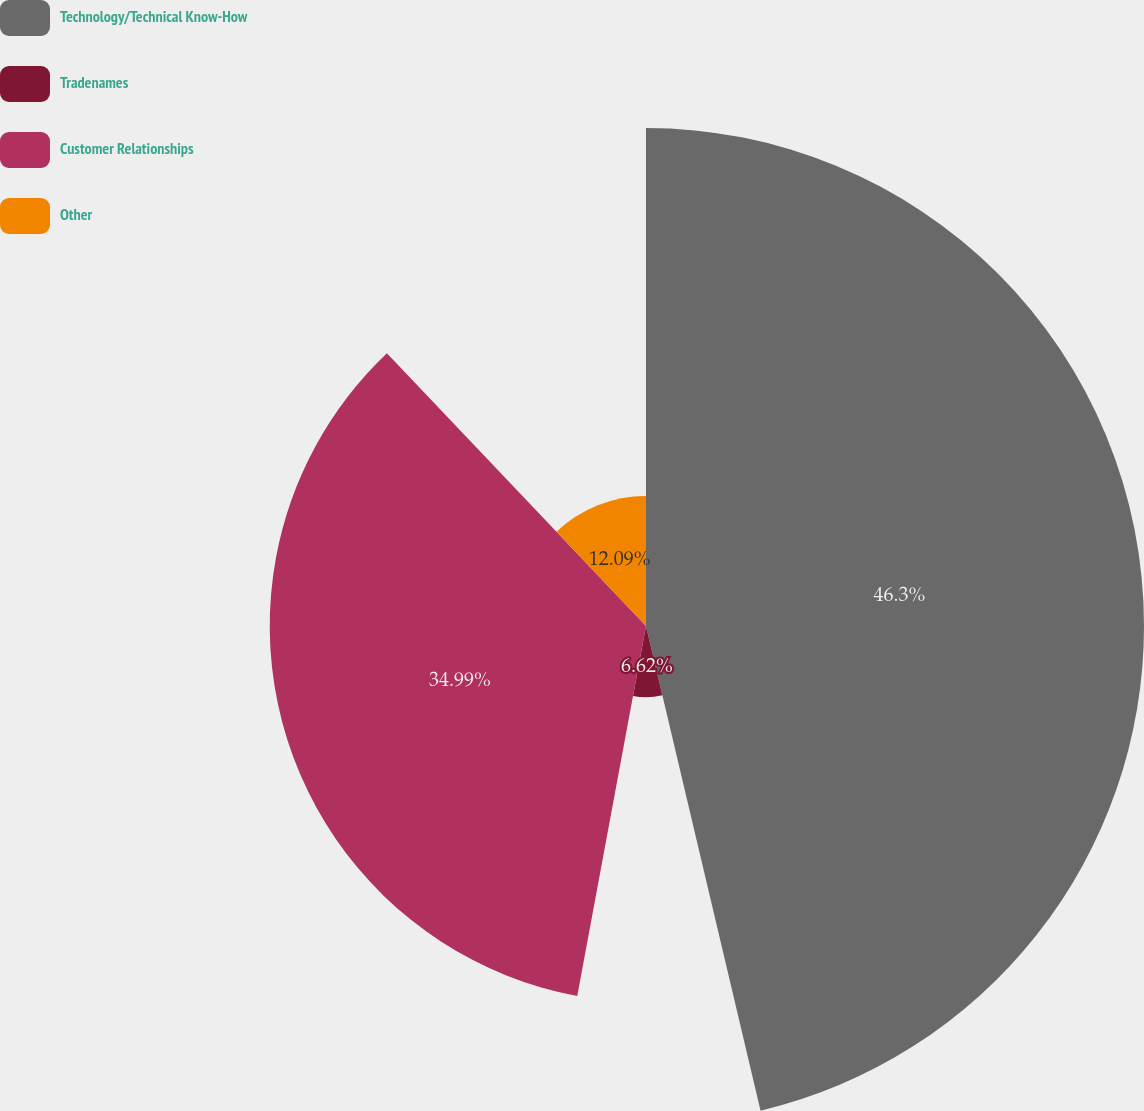<chart> <loc_0><loc_0><loc_500><loc_500><pie_chart><fcel>Technology/Technical Know-How<fcel>Tradenames<fcel>Customer Relationships<fcel>Other<nl><fcel>46.31%<fcel>6.62%<fcel>34.99%<fcel>12.09%<nl></chart> 